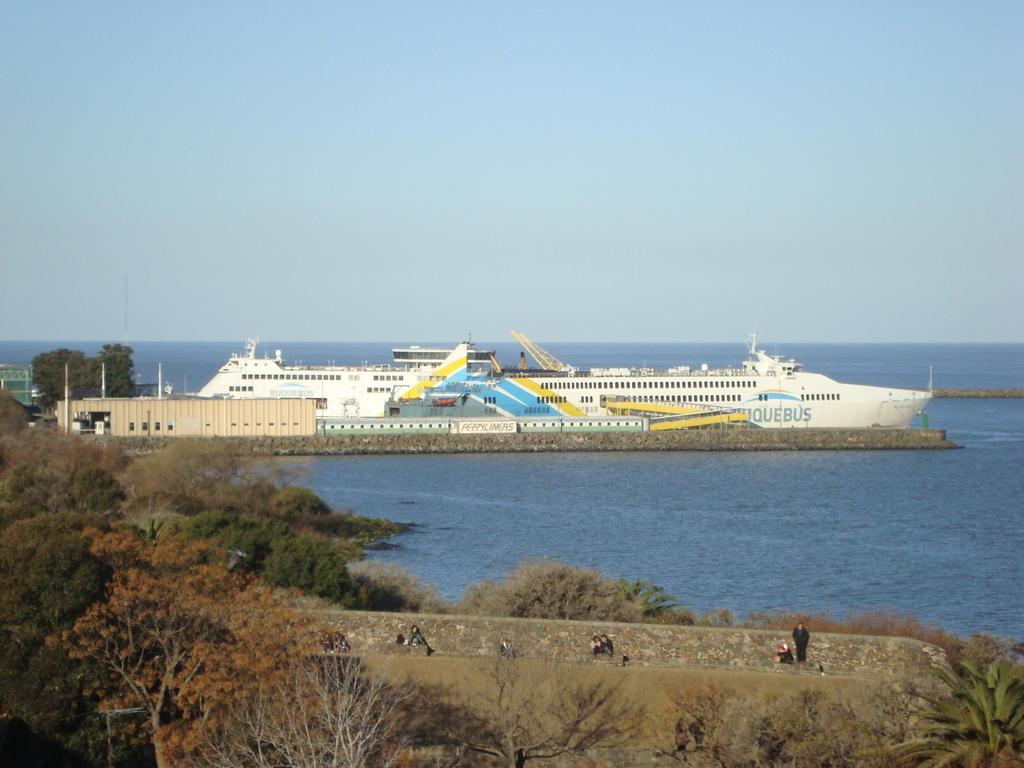Please provide a concise description of this image. In this picture we can see some people, trees, walls, some objects and a ship on the water and in the background we can see the sky. 